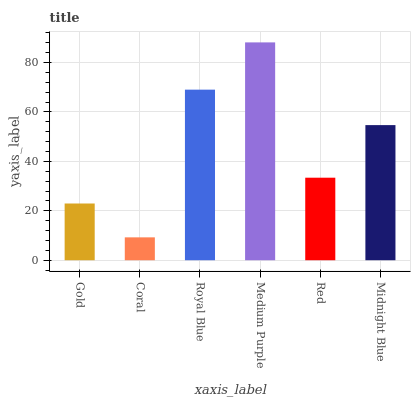Is Coral the minimum?
Answer yes or no. Yes. Is Medium Purple the maximum?
Answer yes or no. Yes. Is Royal Blue the minimum?
Answer yes or no. No. Is Royal Blue the maximum?
Answer yes or no. No. Is Royal Blue greater than Coral?
Answer yes or no. Yes. Is Coral less than Royal Blue?
Answer yes or no. Yes. Is Coral greater than Royal Blue?
Answer yes or no. No. Is Royal Blue less than Coral?
Answer yes or no. No. Is Midnight Blue the high median?
Answer yes or no. Yes. Is Red the low median?
Answer yes or no. Yes. Is Coral the high median?
Answer yes or no. No. Is Medium Purple the low median?
Answer yes or no. No. 